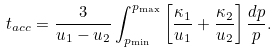<formula> <loc_0><loc_0><loc_500><loc_500>t _ { a c c } = \frac { 3 } { u _ { 1 } - u _ { 2 } } \int ^ { p _ { \max } } _ { p _ { \min } } \left [ \frac { \kappa _ { 1 } } { u _ { 1 } } + \frac { \kappa _ { 2 } } { u _ { 2 } } \right ] \frac { d p } { p } .</formula> 